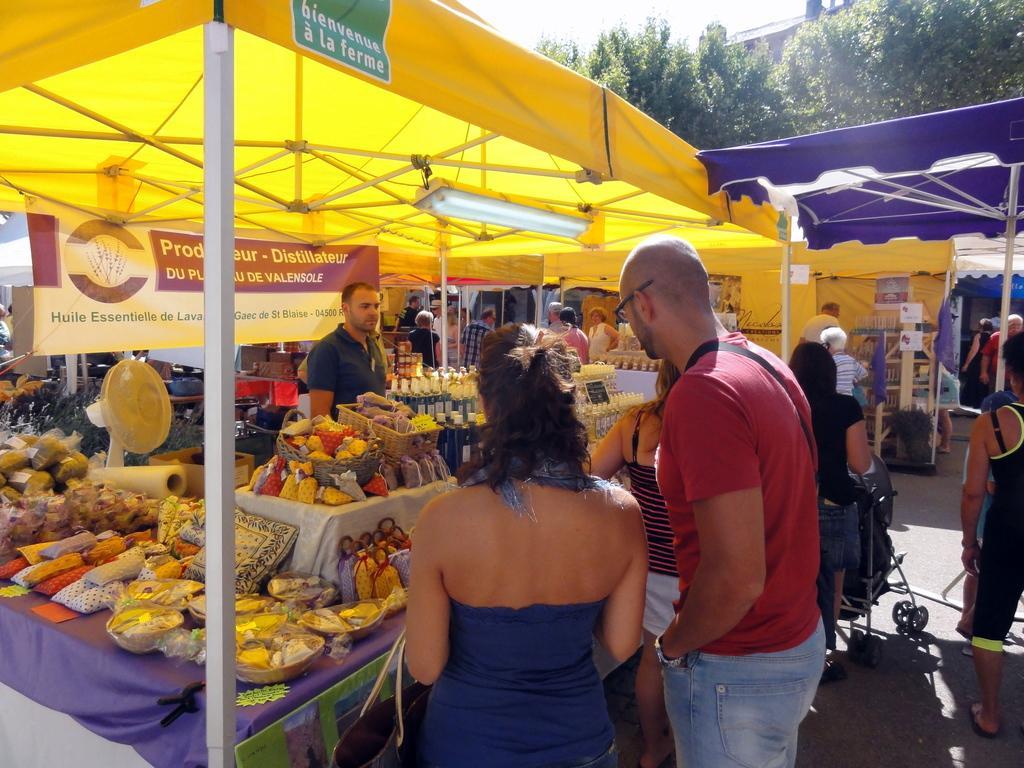In one or two sentences, can you explain what this image depicts? In the center of the image there is a stall in which there are many objects on the table. There is a person standing. In the center of the image there are three persons standing. In the background of the image there are stalls. There are trees. There are people walking on the road. 